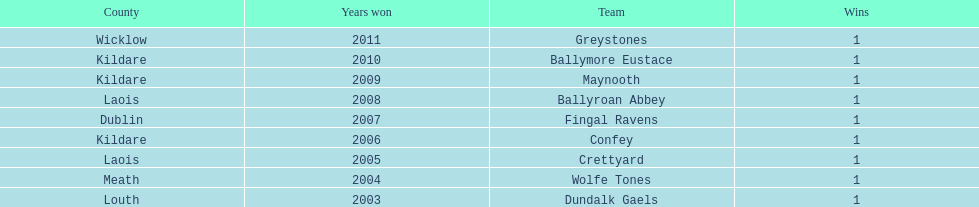What is the difference years won for crettyard and greystones 6. 